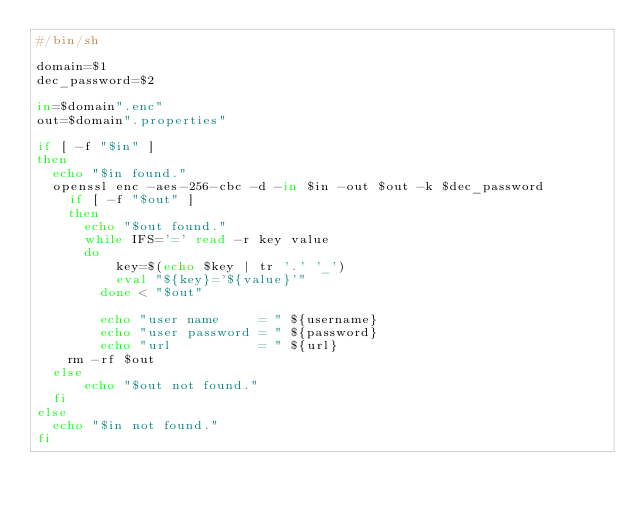Convert code to text. <code><loc_0><loc_0><loc_500><loc_500><_Bash_>#/bin/sh

domain=$1
dec_password=$2

in=$domain".enc"
out=$domain".properties"

if [ -f "$in" ]
then
	echo "$in found."
	openssl enc -aes-256-cbc -d -in $in -out $out -k $dec_password
  	if [ -f "$out" ]
  	then
  		echo "$out found."
  		while IFS='=' read -r key value
  		do
    			key=$(echo $key | tr '.' '_')
    			eval "${key}='${value}'"
  			done < "$out"

  			echo "user name     = " ${username}
  			echo "user password = " ${password}
  			echo "url           = " ${url}
		rm -rf $out
	else
  		echo "$out not found."
	fi
else
	echo "$in not found."
fi
</code> 